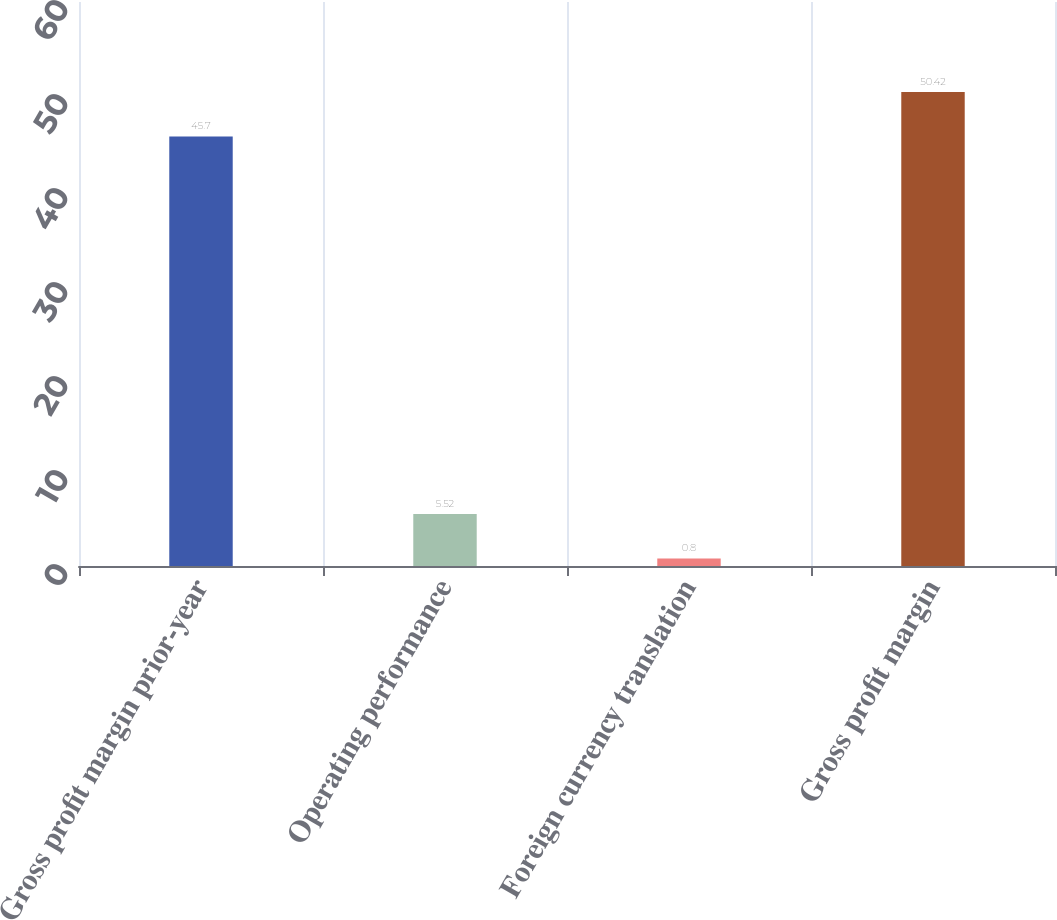Convert chart. <chart><loc_0><loc_0><loc_500><loc_500><bar_chart><fcel>Gross profit margin prior-year<fcel>Operating performance<fcel>Foreign currency translation<fcel>Gross profit margin<nl><fcel>45.7<fcel>5.52<fcel>0.8<fcel>50.42<nl></chart> 